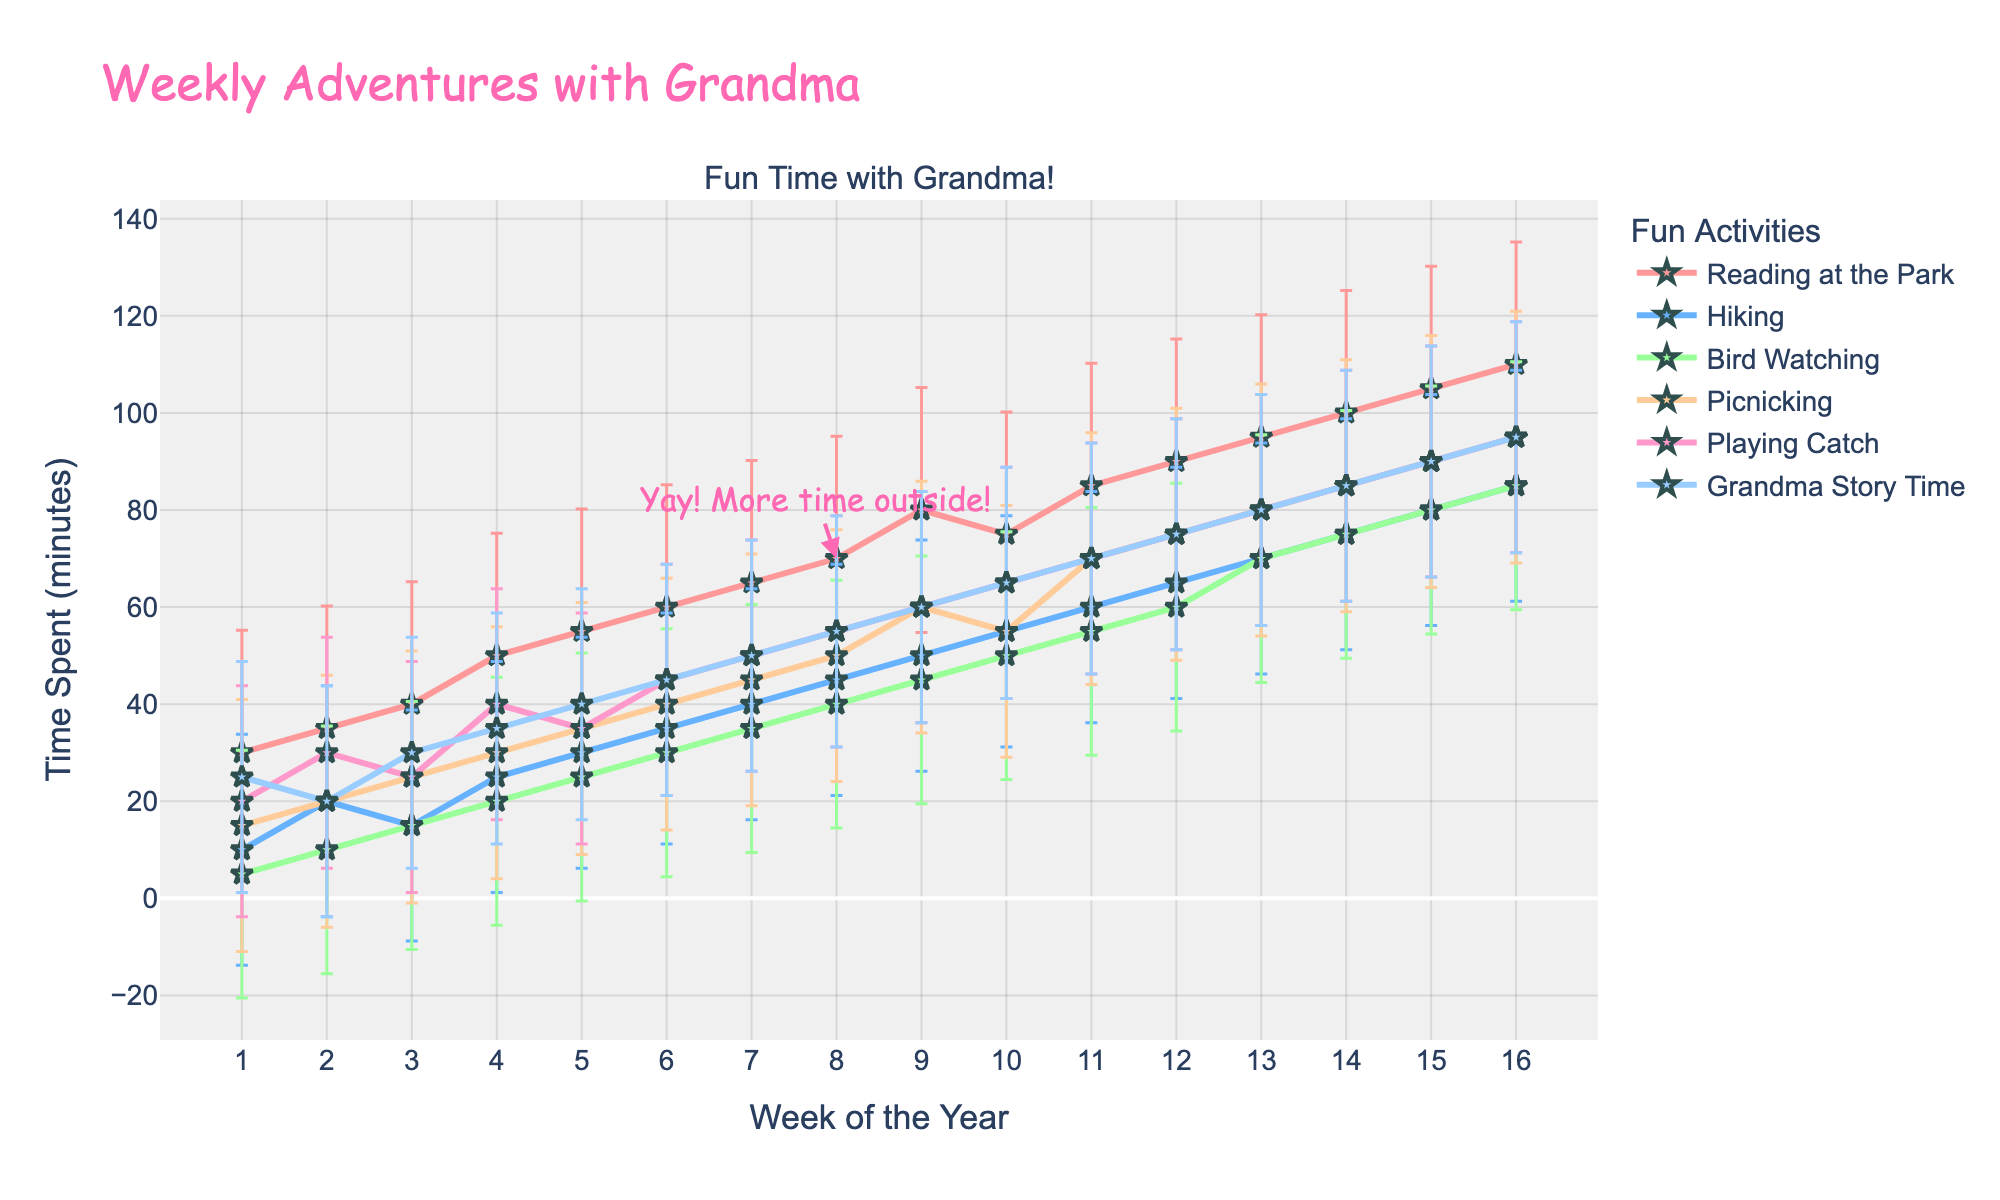Which activity has the most time spent in Week 4? In Week 4, look at the highest point on the line plot to see which activity reached the highest value
Answer: Reading at the Park What is the average time spent on Playing Catch in January? Add the time spent on Playing Catch for all weeks in January (20 + 30 + 25 + 40) and divide by the number of weeks (4)
Answer: 28.75 minutes Does the amount of time spent on Picnicking generally increase or decrease over 16 weeks? Look at the trend line for Picnicking. It starts at 15 minutes in Week 1 and ends up at 95 minutes in Week 16, showing a continuous increase
Answer: Increase Which activity shows the most variation in February? Compare the lengths of the error bars for each activity in February. Longer error bars indicate higher variation
Answer: Playing Catch What can you infer about the error bars' length for Grandma Story Time? Observe that the error bars for Grandma Story Time are consistent and not very long compared to other activities, suggesting little variation
Answer: Low variation Between Hiking and Bird Watching, which had more time spent on average in March? Calculate the average for both activities in March, for Hiking (50 + 55 + 60 + 65)/4 = 57.5 and for Bird Watching (45 + 50 + 55 + 60)/4 = 52.5, then compare
Answer: Hiking How does the time spent on Reading at the Park in January compare to April? Compare the values: In January, times are (30 + 35 + 40 + 50), and in April, times are (95 + 100 + 105 + 110). Clearly, the values are much higher in April
Answer: Higher in April What do the cheerful annotations about spending more time outside suggest? The annotation "Yay! More time outside!" points specifically at Week 8 with increased outdoor activity time, specifically highlighting a general trend
Answer: Increased outdoor activity around Week 8 What's the total time spent on all activities in Week 9? Sum the times spent on each activity in Week 9: (80 + 50 + 45 + 60 + 60 + 60)
Answer: 355 minutes By how much did time spent on Picnicking increase from Week 1 to Week 12? Subtract the Week 1 value from the Week 12 value for Picnicking: (75 - 15)
Answer: 60 minutes 